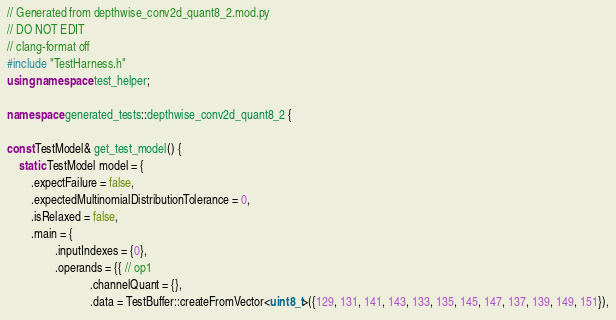<code> <loc_0><loc_0><loc_500><loc_500><_C++_>// Generated from depthwise_conv2d_quant8_2.mod.py
// DO NOT EDIT
// clang-format off
#include "TestHarness.h"
using namespace test_helper;

namespace generated_tests::depthwise_conv2d_quant8_2 {

const TestModel& get_test_model() {
    static TestModel model = {
        .expectFailure = false,
        .expectedMultinomialDistributionTolerance = 0,
        .isRelaxed = false,
        .main = {
                .inputIndexes = {0},
                .operands = {{ // op1
                            .channelQuant = {},
                            .data = TestBuffer::createFromVector<uint8_t>({129, 131, 141, 143, 133, 135, 145, 147, 137, 139, 149, 151}),</code> 